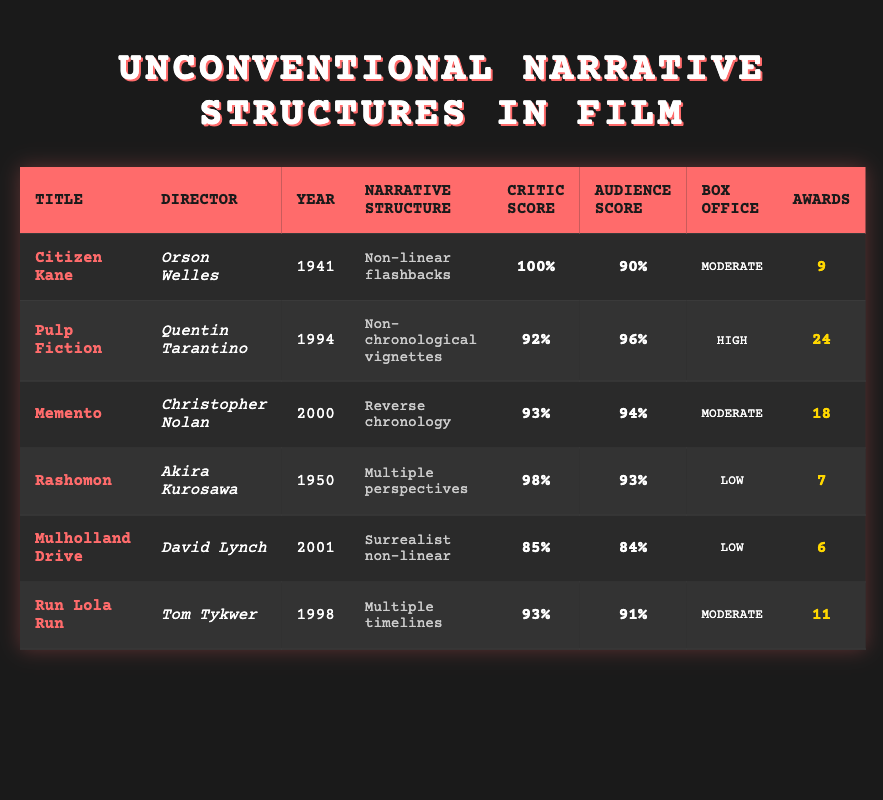What is the critic score of "Citizen Kane"? The table lists the critic score for "Citizen Kane" in the appropriate column, which shows a score of 100%.
Answer: 100% Which film has the highest audience score? By examining the audience scores in the table, "Pulp Fiction" has the highest score at 96%.
Answer: Pulp Fiction How many awards did "Mulholland Drive" win? Looking at the awards column, "Mulholland Drive" is indicated to have won 6 awards.
Answer: 6 What is the average critic score of the films listed? To find the average, we first sum the critic scores: 100 + 92 + 93 + 98 + 85 + 93 = 561. Then, divide by the number of films, which is 6. Thus, the average is 561/6 = 93.5.
Answer: 93.5 Did "Rashomon" score higher with critics than "Memento"? Checking the critic scores, "Rashomon" has a score of 98% while "Memento" has 93%. Since 98% is greater than 93%, the statement is true.
Answer: Yes Which film has a moderate box office success and the lowest audience score? The table shows that both "Citizen Kane," "Memento," and "Run Lola Run" have moderate box office success. However, out of these three, "Citizen Kane" has the lowest audience score of 90%.
Answer: Citizen Kane How many more awards did "Pulp Fiction" win compared to "Mulholland Drive"? "Pulp Fiction" has won 24 awards, while "Mulholland Drive" won 6. The difference is 24 - 6 = 18.
Answer: 18 Which film directed by Christopher Nolan has a higher audience score than "Rashomon"? "Memento," directed by Christopher Nolan, has an audience score of 94%, which is higher than "Rashomon," which has a score of 93%.
Answer: Yes Is the audience score for "Run Lola Run" and "Mulholland Drive" the same? The audience score for "Run Lola Run" is 91%, while "Mulholland Drive" has an audience score of 84%. Since they are different, the answer is no.
Answer: No 